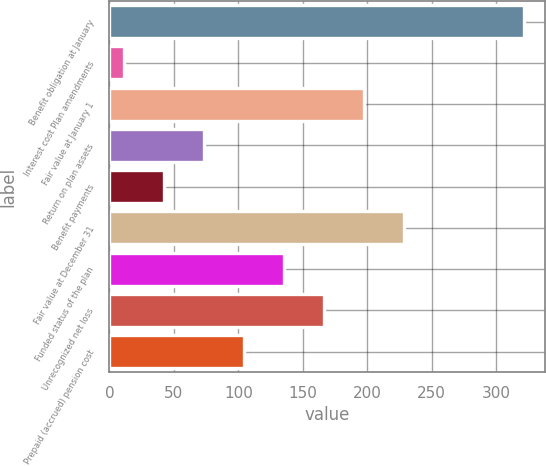Convert chart to OTSL. <chart><loc_0><loc_0><loc_500><loc_500><bar_chart><fcel>Benefit obligation at January<fcel>Interest cost Plan amendments<fcel>Fair value at January 1<fcel>Return on plan assets<fcel>Benefit payments<fcel>Fair value at December 31<fcel>Funded status of the plan<fcel>Unrecognized net loss<fcel>Prepaid (accrued) pension cost<nl><fcel>322<fcel>11<fcel>197.6<fcel>73.2<fcel>42.1<fcel>228.7<fcel>135.4<fcel>166.5<fcel>104.3<nl></chart> 